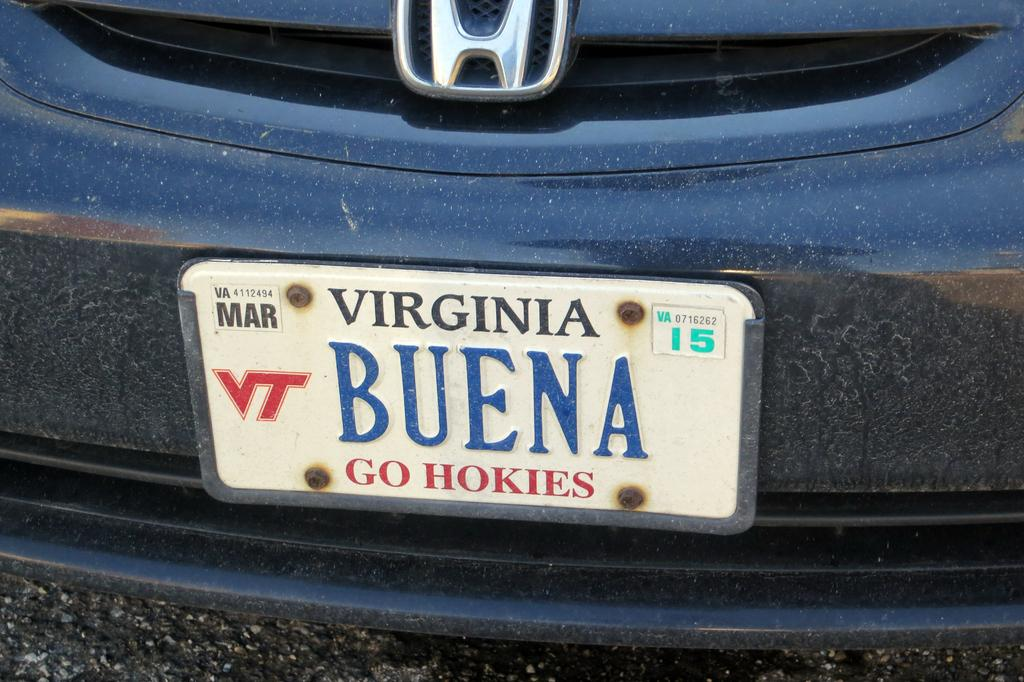What object in the image has a nameplate on it? There is a nameplate on a car in the image. What type of lumber is being transported by the car in the image? There is no lumber visible in the image, and the car's purpose is not specified. How many fire hydrants are present near the car in the image? There is no fire hydrant visible in the image. 